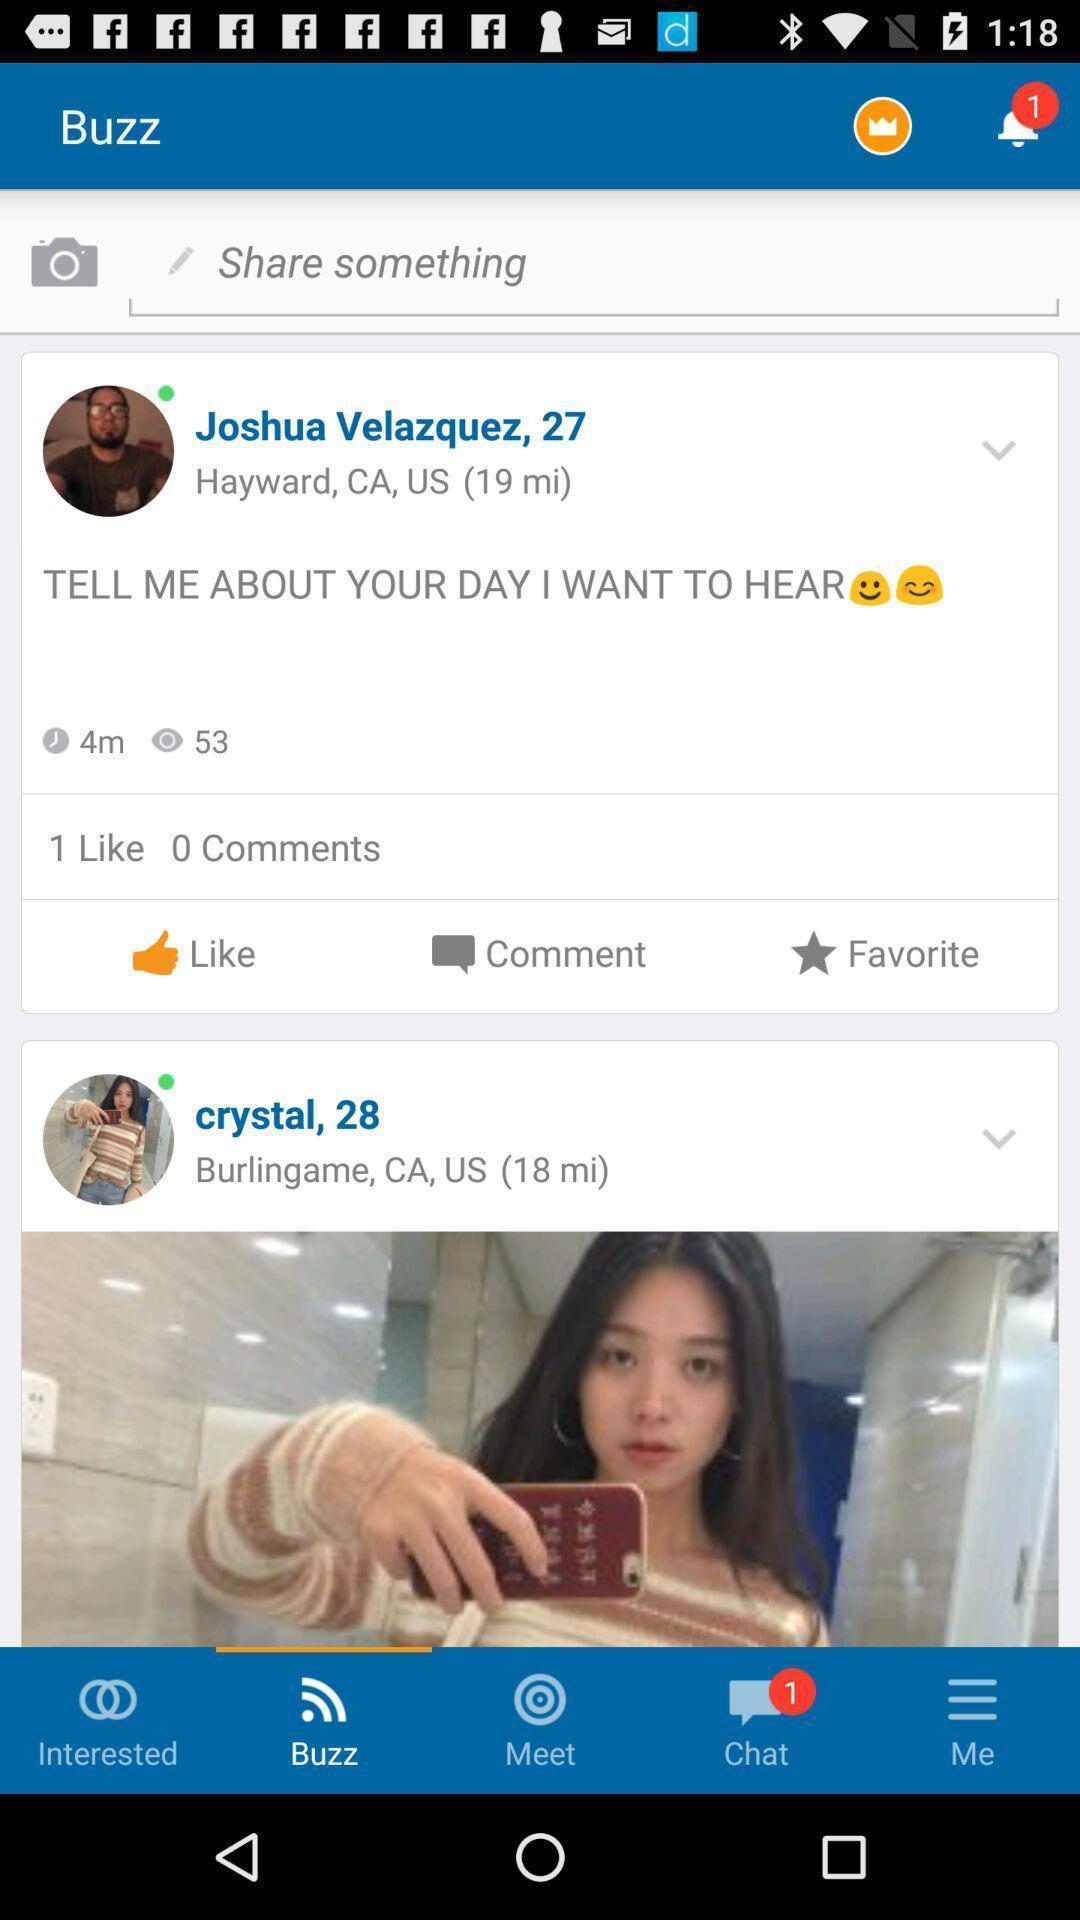What details can you identify in this image? Screen showing post 's in an social application. 